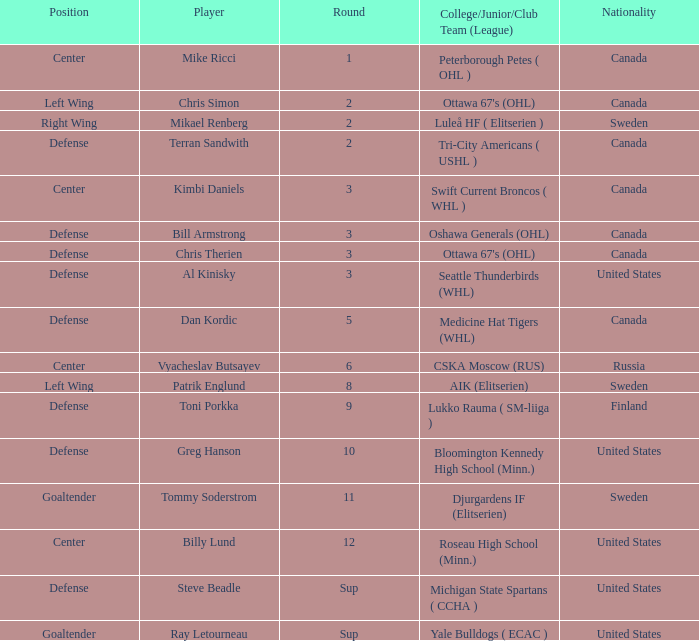What is the school that hosts mikael renberg Luleå HF ( Elitserien ). 